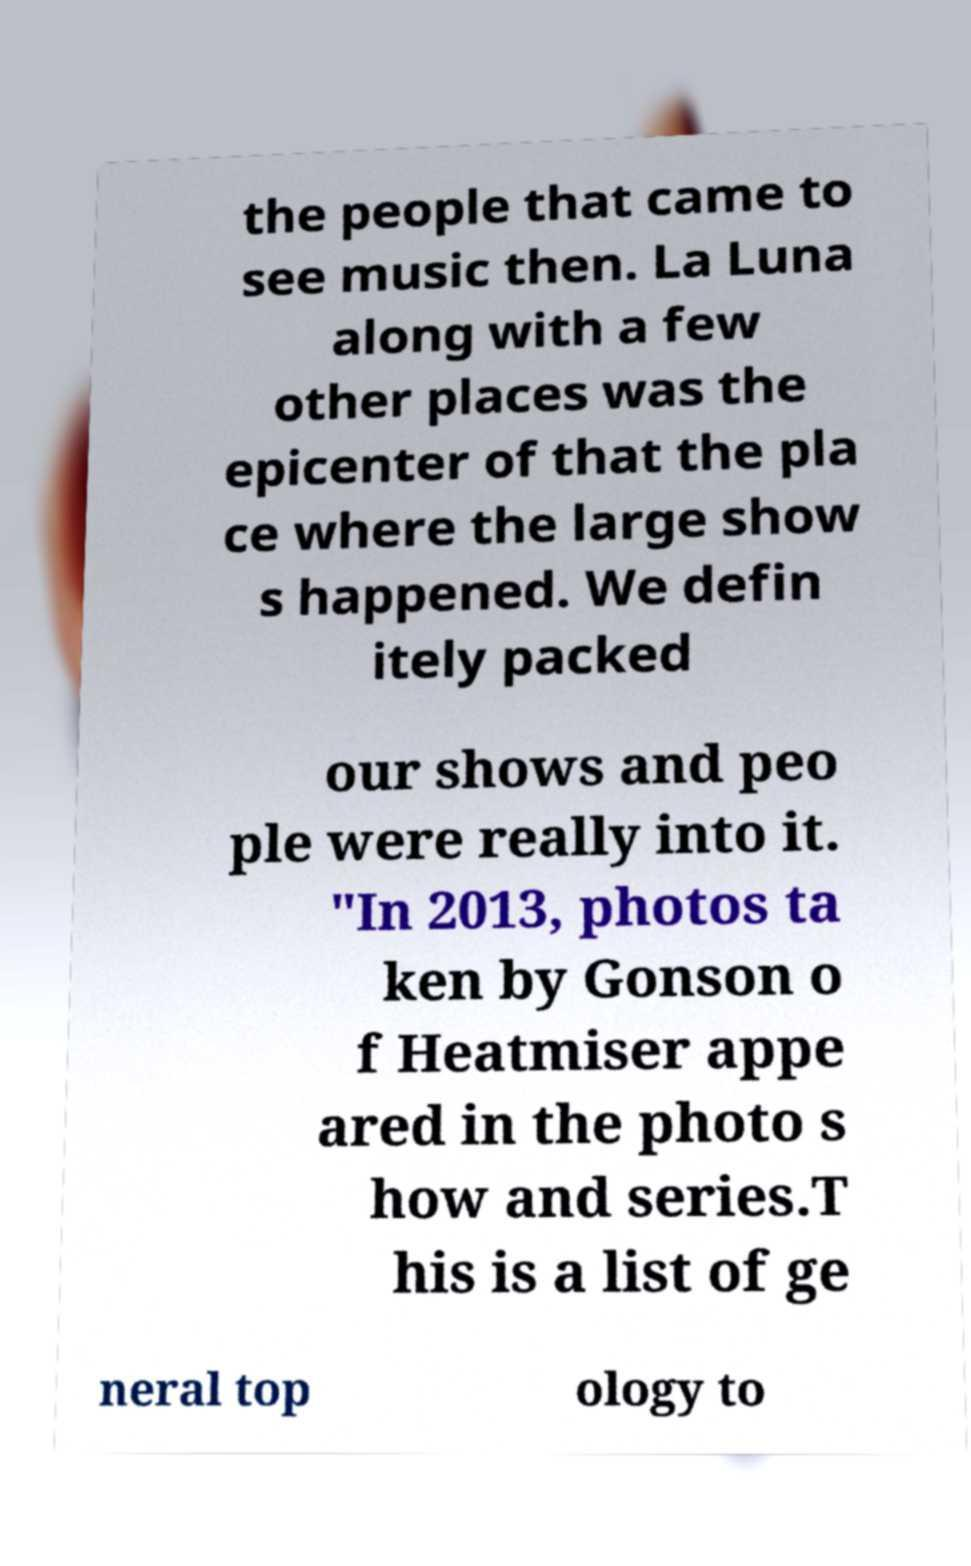What messages or text are displayed in this image? I need them in a readable, typed format. the people that came to see music then. La Luna along with a few other places was the epicenter of that the pla ce where the large show s happened. We defin itely packed our shows and peo ple were really into it. "In 2013, photos ta ken by Gonson o f Heatmiser appe ared in the photo s how and series.T his is a list of ge neral top ology to 